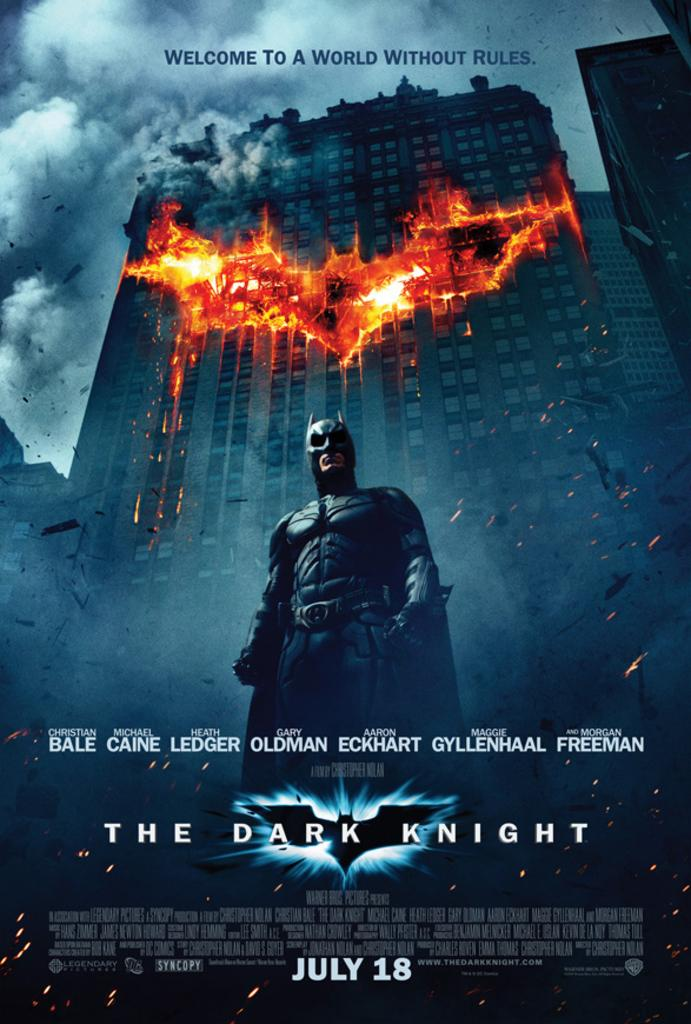<image>
Share a concise interpretation of the image provided. The Dark Knight, a Batman film, releases on July 18th. 